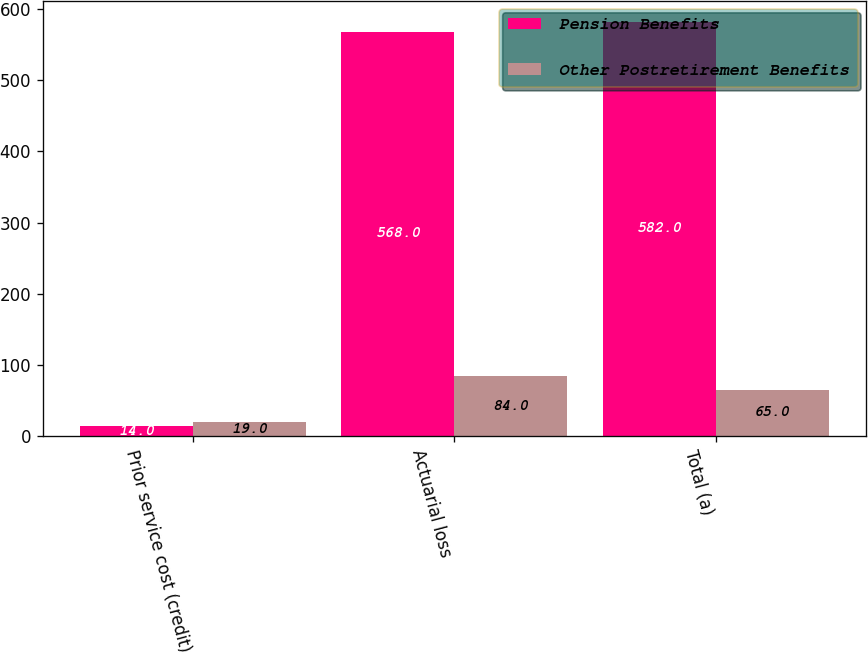Convert chart to OTSL. <chart><loc_0><loc_0><loc_500><loc_500><stacked_bar_chart><ecel><fcel>Prior service cost (credit)<fcel>Actuarial loss<fcel>Total (a)<nl><fcel>Pension Benefits<fcel>14<fcel>568<fcel>582<nl><fcel>Other Postretirement Benefits<fcel>19<fcel>84<fcel>65<nl></chart> 